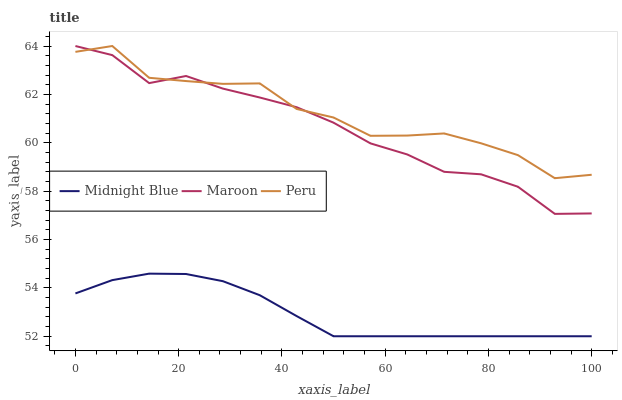Does Midnight Blue have the minimum area under the curve?
Answer yes or no. Yes. Does Peru have the maximum area under the curve?
Answer yes or no. Yes. Does Maroon have the minimum area under the curve?
Answer yes or no. No. Does Maroon have the maximum area under the curve?
Answer yes or no. No. Is Midnight Blue the smoothest?
Answer yes or no. Yes. Is Peru the roughest?
Answer yes or no. Yes. Is Maroon the smoothest?
Answer yes or no. No. Is Maroon the roughest?
Answer yes or no. No. Does Maroon have the lowest value?
Answer yes or no. No. Does Midnight Blue have the highest value?
Answer yes or no. No. Is Midnight Blue less than Peru?
Answer yes or no. Yes. Is Maroon greater than Midnight Blue?
Answer yes or no. Yes. Does Midnight Blue intersect Peru?
Answer yes or no. No. 